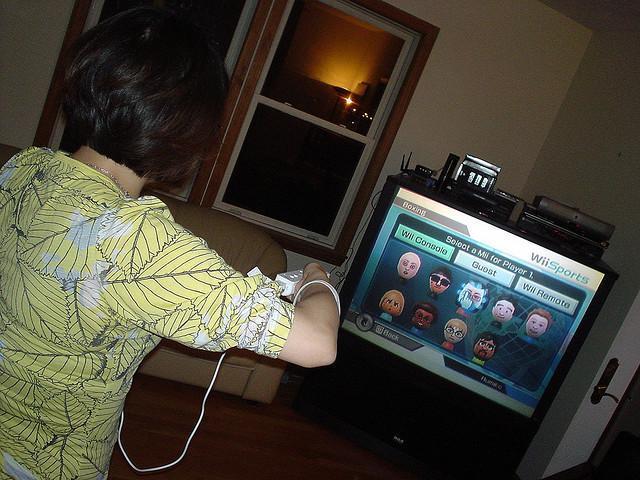Is the given caption "The person is at the left side of the tv." fitting for the image?
Answer yes or no. Yes. 